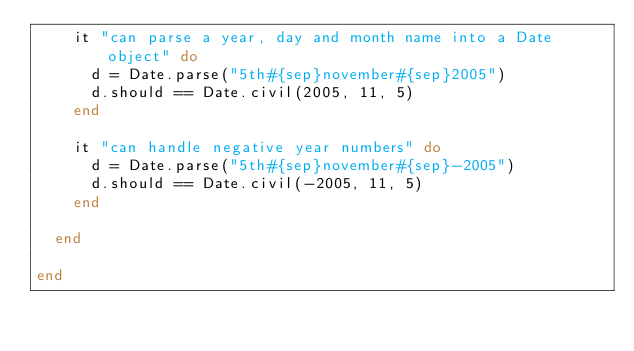Convert code to text. <code><loc_0><loc_0><loc_500><loc_500><_Ruby_>    it "can parse a year, day and month name into a Date object" do
      d = Date.parse("5th#{sep}november#{sep}2005")
      d.should == Date.civil(2005, 11, 5)
    end
    
    it "can handle negative year numbers" do
      d = Date.parse("5th#{sep}november#{sep}-2005")
      d.should == Date.civil(-2005, 11, 5)
    end

  end

end</code> 